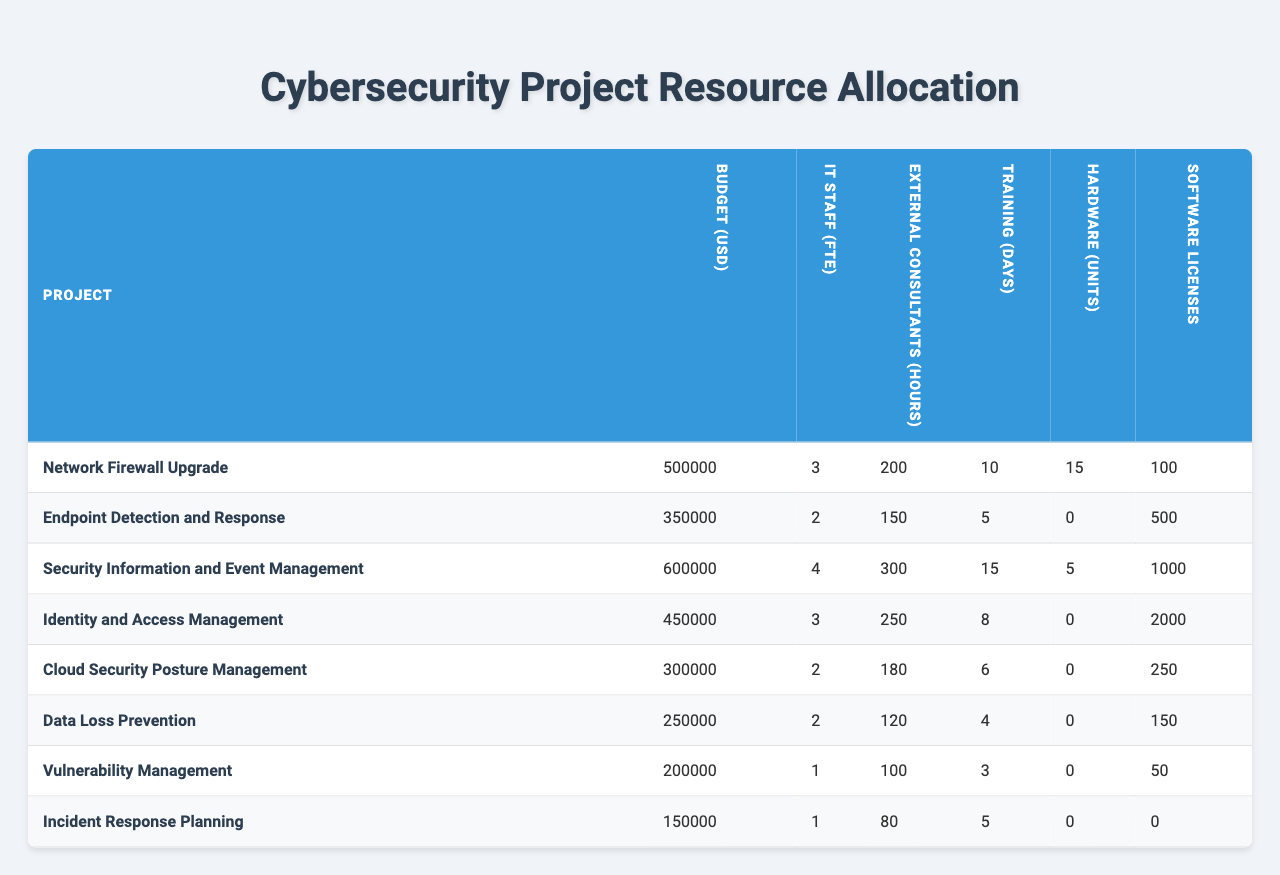What is the total budget allocated for all projects? To find the total budget, sum the budget allocations for each project: 500000 + 350000 + 600000 + 450000 + 300000 + 250000 + 200000 + 150000 = 2800000
Answer: 2800000 Which project has the highest allocation of IT staff? The project with the highest IT staff allocation is "Security Information and Event Management" with 4 FTE.
Answer: Security Information and Event Management How many software licenses are allocated for the "Data Loss Prevention" project? The table shows that the "Data Loss Prevention" project has 150 software licenses allocated.
Answer: 150 What is the average number of external consulting hours allocated across all projects? First, sum the external consultant hours: 200 + 150 + 300 + 250 + 180 + 120 + 100 + 80 = 1380. There are 8 projects, so the average is 1380 / 8 = 172.5.
Answer: 172.5 Is there any project that does not require hardware units? Yes, both "Cloud Security Posture Management" and "Data Loss Prevention" projects do not require any hardware units (0 units allocated).
Answer: Yes Which project requires the most training days? "Security Information and Event Management" requires the most training days, totaling 15 days.
Answer: Security Information and Event Management How does the total budget allocated to "Identity and Access Management" compare to the total budget for "Incident Response Planning"? The budget for "Identity and Access Management" is 450000, while the budget for "Incident Response Planning" is 150000. Thus, 450000 is greater than 150000 by 300000.
Answer: 300000 What is the total number of hardware units allocated for the projects that require them? Summing the hardware units: 15 + 0 + 5 + 0 + 0 + 0 + 0 + 0 = 20. Thus, the total hardware units for projects that require them is 20.
Answer: 20 Which project has the least overall resource allocation, considering all categories? Adding up each project's allocations gives: Network Firewall Upgrade = 500000 + 3 + 200 + 10 + 15 + 100 = 500328, Endpoint Detection and Response = 350000 + 2 + 150 + 5 + 0 + 500 = 350657, etc. The project with the least total is "Incident Response Planning" with 150000 + 1 + 80 + 5 + 0 + 0 = 150086.
Answer: Incident Response Planning How many training days are allocated to projects that spend more than 400000 on the budget? The projects that exceed 400000 are "Network Firewall Upgrade," "Security Information and Event Management," and "Identity and Access Management," which collectively allocate (10 + 15 + 8) training days = 33 days.
Answer: 33 